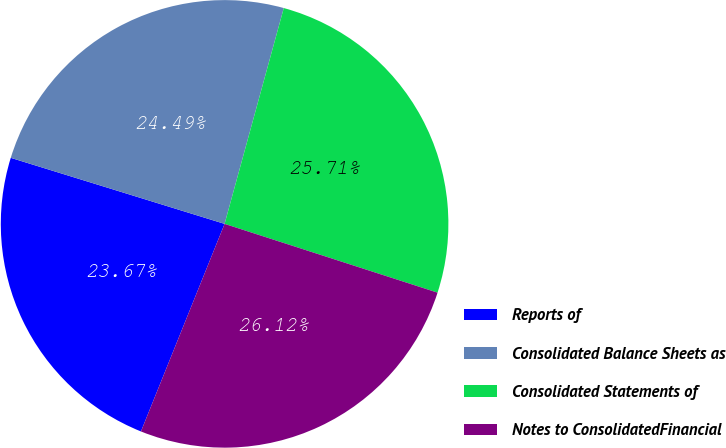Convert chart. <chart><loc_0><loc_0><loc_500><loc_500><pie_chart><fcel>Reports of<fcel>Consolidated Balance Sheets as<fcel>Consolidated Statements of<fcel>Notes to ConsolidatedFinancial<nl><fcel>23.67%<fcel>24.49%<fcel>25.71%<fcel>26.12%<nl></chart> 